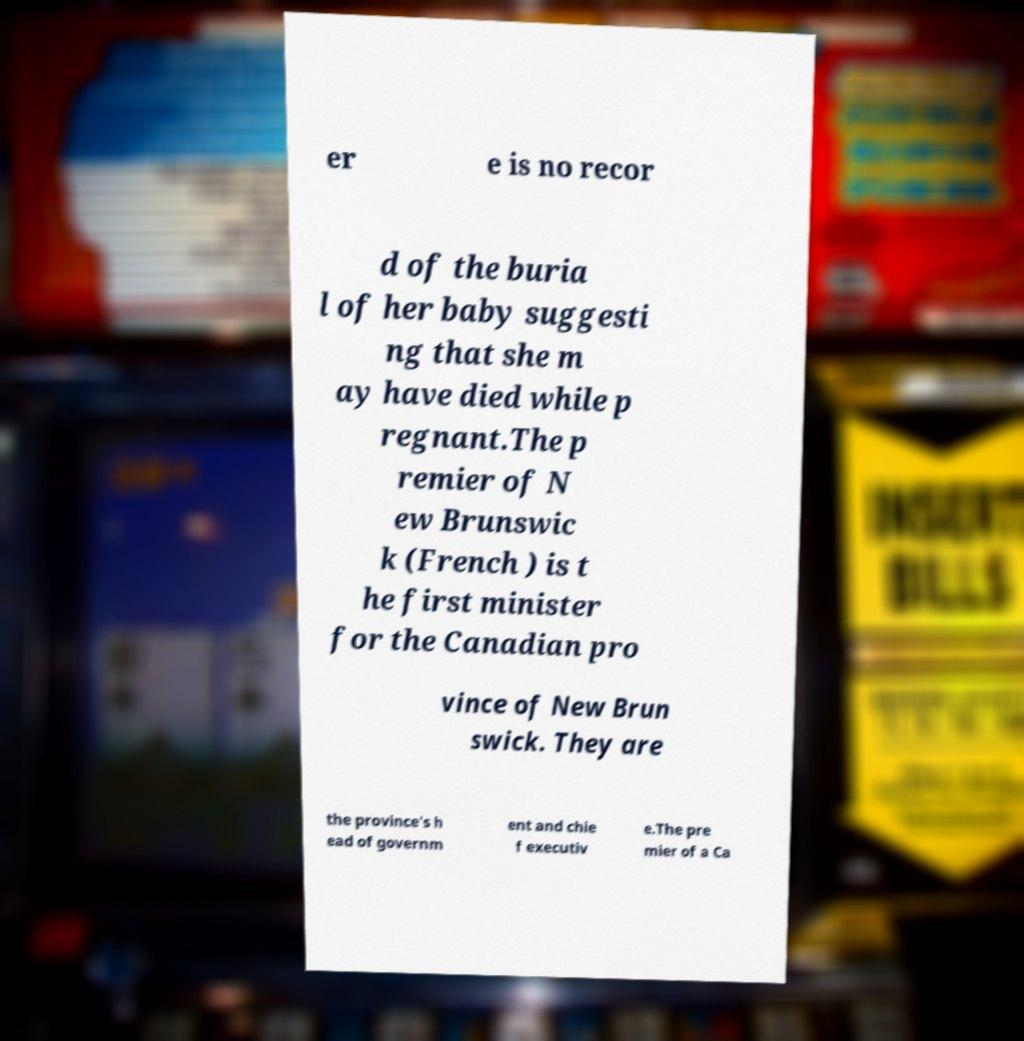Please read and relay the text visible in this image. What does it say? er e is no recor d of the buria l of her baby suggesti ng that she m ay have died while p regnant.The p remier of N ew Brunswic k (French ) is t he first minister for the Canadian pro vince of New Brun swick. They are the province's h ead of governm ent and chie f executiv e.The pre mier of a Ca 